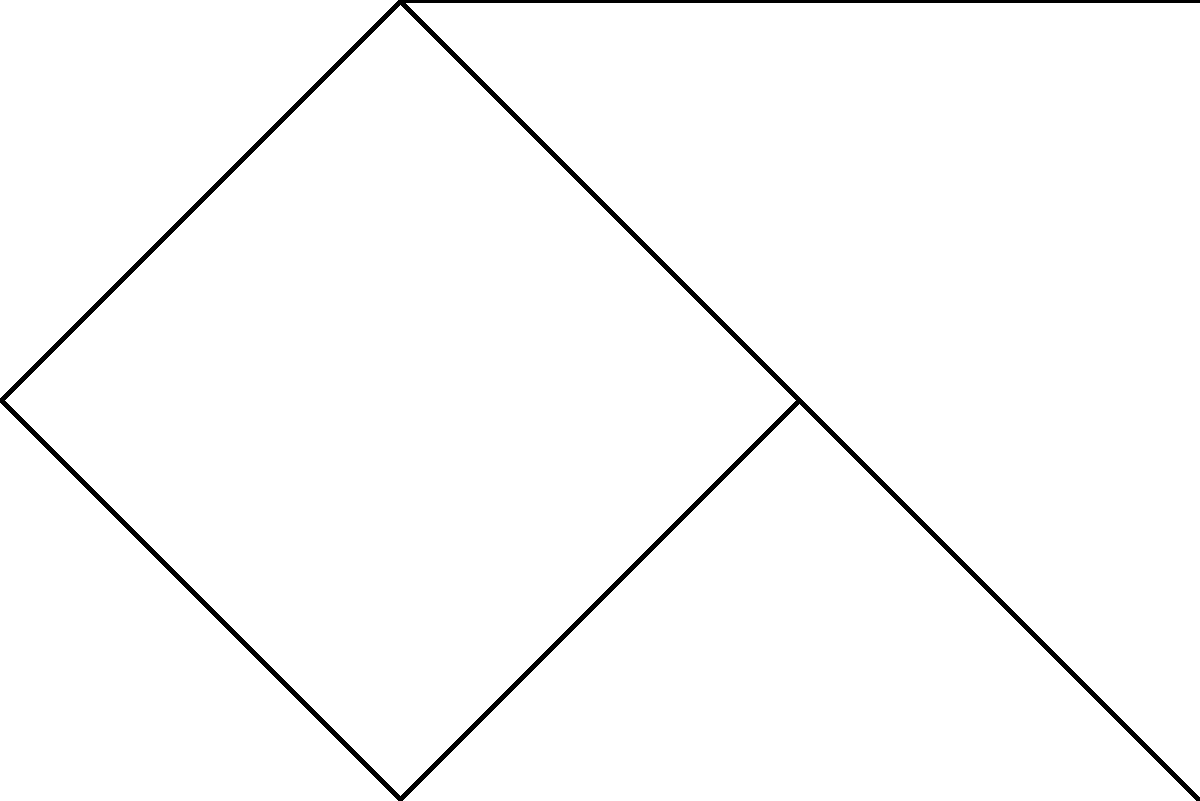In the given network topology, nodes A, B, C, and D form a ring network, while nodes E and F are connected as leaf nodes. If we consider the ring nodes as routers and the leaf nodes as end devices, what is the minimum number of hops required for a packet to travel from node E to node F? To determine the minimum number of hops for a packet to travel from node E to node F, we need to follow these steps:

1. Identify the entry point to the ring network:
   Node E is connected to node B, so B is the entry point.

2. Identify the exit point from the ring network:
   Node F is connected to node C, so C is the exit point.

3. Calculate the shortest path within the ring:
   From B to C, we have two options:
   a. B -> C (1 hop)
   b. B -> A -> D -> C (3 hops)
   The shortest path is B -> C (1 hop).

4. Count the total hops:
   - From E to B: 1 hop
   - From B to C: 1 hop
   - From C to F: 1 hop

5. Sum up the hops:
   Total minimum hops = 1 + 1 + 1 = 3 hops

Therefore, the minimum number of hops required for a packet to travel from node E to node F is 3.
Answer: 3 hops 